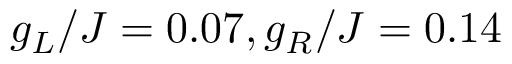Convert formula to latex. <formula><loc_0><loc_0><loc_500><loc_500>g _ { L } / J = 0 . 0 7 , g _ { R } / J = 0 . 1 4</formula> 